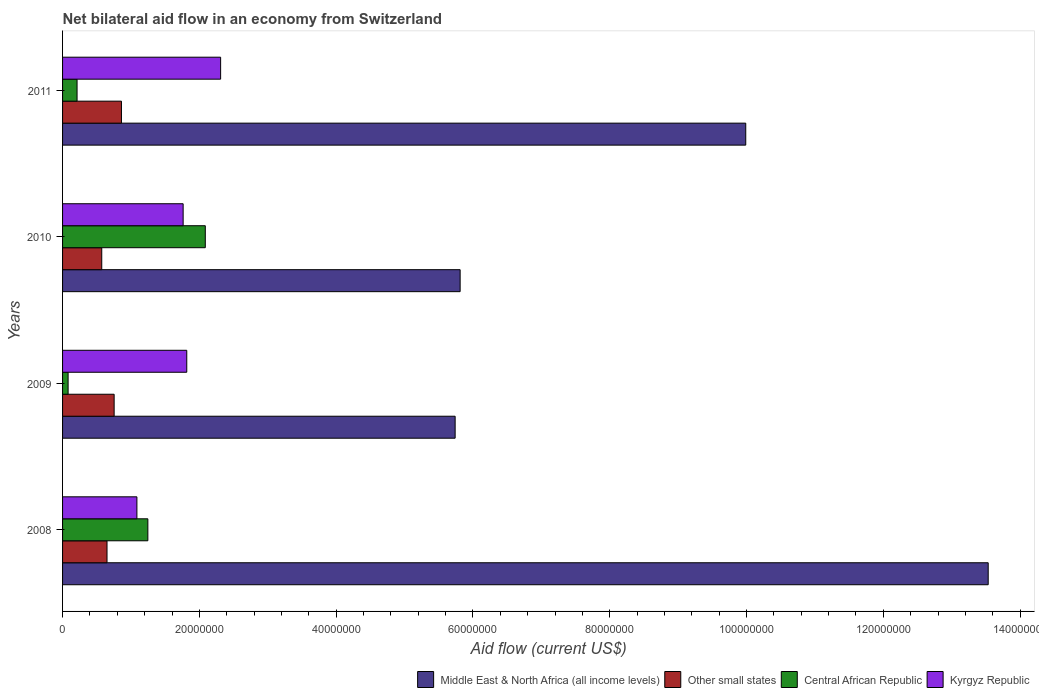Are the number of bars per tick equal to the number of legend labels?
Your answer should be very brief. Yes. How many bars are there on the 1st tick from the top?
Your response must be concise. 4. What is the net bilateral aid flow in Other small states in 2010?
Keep it short and to the point. 5.73e+06. Across all years, what is the maximum net bilateral aid flow in Middle East & North Africa (all income levels)?
Provide a short and direct response. 1.35e+08. Across all years, what is the minimum net bilateral aid flow in Middle East & North Africa (all income levels)?
Keep it short and to the point. 5.74e+07. What is the total net bilateral aid flow in Middle East & North Africa (all income levels) in the graph?
Provide a succinct answer. 3.51e+08. What is the difference between the net bilateral aid flow in Middle East & North Africa (all income levels) in 2008 and that in 2011?
Ensure brevity in your answer.  3.54e+07. What is the difference between the net bilateral aid flow in Kyrgyz Republic in 2009 and the net bilateral aid flow in Other small states in 2008?
Your answer should be very brief. 1.17e+07. What is the average net bilateral aid flow in Central African Republic per year?
Your answer should be very brief. 9.07e+06. In the year 2010, what is the difference between the net bilateral aid flow in Middle East & North Africa (all income levels) and net bilateral aid flow in Central African Republic?
Offer a terse response. 3.73e+07. What is the ratio of the net bilateral aid flow in Middle East & North Africa (all income levels) in 2008 to that in 2010?
Your answer should be compact. 2.33. What is the difference between the highest and the second highest net bilateral aid flow in Central African Republic?
Your response must be concise. 8.40e+06. What is the difference between the highest and the lowest net bilateral aid flow in Central African Republic?
Your answer should be compact. 2.01e+07. In how many years, is the net bilateral aid flow in Middle East & North Africa (all income levels) greater than the average net bilateral aid flow in Middle East & North Africa (all income levels) taken over all years?
Keep it short and to the point. 2. What does the 3rd bar from the top in 2009 represents?
Your response must be concise. Other small states. What does the 3rd bar from the bottom in 2011 represents?
Your answer should be very brief. Central African Republic. Is it the case that in every year, the sum of the net bilateral aid flow in Central African Republic and net bilateral aid flow in Kyrgyz Republic is greater than the net bilateral aid flow in Middle East & North Africa (all income levels)?
Offer a very short reply. No. Are all the bars in the graph horizontal?
Make the answer very short. Yes. What is the difference between two consecutive major ticks on the X-axis?
Offer a very short reply. 2.00e+07. Are the values on the major ticks of X-axis written in scientific E-notation?
Offer a very short reply. No. Does the graph contain grids?
Give a very brief answer. No. Where does the legend appear in the graph?
Ensure brevity in your answer.  Bottom right. How many legend labels are there?
Your answer should be very brief. 4. How are the legend labels stacked?
Your answer should be very brief. Horizontal. What is the title of the graph?
Ensure brevity in your answer.  Net bilateral aid flow in an economy from Switzerland. What is the Aid flow (current US$) of Middle East & North Africa (all income levels) in 2008?
Your answer should be very brief. 1.35e+08. What is the Aid flow (current US$) of Other small states in 2008?
Make the answer very short. 6.50e+06. What is the Aid flow (current US$) in Central African Republic in 2008?
Your answer should be very brief. 1.25e+07. What is the Aid flow (current US$) in Kyrgyz Republic in 2008?
Provide a succinct answer. 1.09e+07. What is the Aid flow (current US$) of Middle East & North Africa (all income levels) in 2009?
Give a very brief answer. 5.74e+07. What is the Aid flow (current US$) of Other small states in 2009?
Your answer should be compact. 7.54e+06. What is the Aid flow (current US$) of Central African Republic in 2009?
Give a very brief answer. 8.10e+05. What is the Aid flow (current US$) of Kyrgyz Republic in 2009?
Provide a short and direct response. 1.82e+07. What is the Aid flow (current US$) of Middle East & North Africa (all income levels) in 2010?
Make the answer very short. 5.81e+07. What is the Aid flow (current US$) of Other small states in 2010?
Provide a short and direct response. 5.73e+06. What is the Aid flow (current US$) of Central African Republic in 2010?
Ensure brevity in your answer.  2.09e+07. What is the Aid flow (current US$) of Kyrgyz Republic in 2010?
Provide a short and direct response. 1.76e+07. What is the Aid flow (current US$) of Middle East & North Africa (all income levels) in 2011?
Your answer should be compact. 9.99e+07. What is the Aid flow (current US$) in Other small states in 2011?
Keep it short and to the point. 8.61e+06. What is the Aid flow (current US$) in Central African Republic in 2011?
Offer a very short reply. 2.12e+06. What is the Aid flow (current US$) in Kyrgyz Republic in 2011?
Provide a succinct answer. 2.31e+07. Across all years, what is the maximum Aid flow (current US$) of Middle East & North Africa (all income levels)?
Your answer should be very brief. 1.35e+08. Across all years, what is the maximum Aid flow (current US$) in Other small states?
Your answer should be very brief. 8.61e+06. Across all years, what is the maximum Aid flow (current US$) in Central African Republic?
Offer a terse response. 2.09e+07. Across all years, what is the maximum Aid flow (current US$) in Kyrgyz Republic?
Give a very brief answer. 2.31e+07. Across all years, what is the minimum Aid flow (current US$) of Middle East & North Africa (all income levels)?
Your response must be concise. 5.74e+07. Across all years, what is the minimum Aid flow (current US$) of Other small states?
Give a very brief answer. 5.73e+06. Across all years, what is the minimum Aid flow (current US$) in Central African Republic?
Offer a very short reply. 8.10e+05. Across all years, what is the minimum Aid flow (current US$) of Kyrgyz Republic?
Offer a very short reply. 1.09e+07. What is the total Aid flow (current US$) in Middle East & North Africa (all income levels) in the graph?
Ensure brevity in your answer.  3.51e+08. What is the total Aid flow (current US$) of Other small states in the graph?
Offer a terse response. 2.84e+07. What is the total Aid flow (current US$) in Central African Republic in the graph?
Ensure brevity in your answer.  3.63e+07. What is the total Aid flow (current US$) in Kyrgyz Republic in the graph?
Keep it short and to the point. 6.98e+07. What is the difference between the Aid flow (current US$) in Middle East & North Africa (all income levels) in 2008 and that in 2009?
Ensure brevity in your answer.  7.79e+07. What is the difference between the Aid flow (current US$) in Other small states in 2008 and that in 2009?
Your answer should be very brief. -1.04e+06. What is the difference between the Aid flow (current US$) of Central African Republic in 2008 and that in 2009?
Make the answer very short. 1.17e+07. What is the difference between the Aid flow (current US$) of Kyrgyz Republic in 2008 and that in 2009?
Make the answer very short. -7.29e+06. What is the difference between the Aid flow (current US$) in Middle East & North Africa (all income levels) in 2008 and that in 2010?
Make the answer very short. 7.72e+07. What is the difference between the Aid flow (current US$) in Other small states in 2008 and that in 2010?
Give a very brief answer. 7.70e+05. What is the difference between the Aid flow (current US$) of Central African Republic in 2008 and that in 2010?
Your response must be concise. -8.40e+06. What is the difference between the Aid flow (current US$) in Kyrgyz Republic in 2008 and that in 2010?
Offer a very short reply. -6.76e+06. What is the difference between the Aid flow (current US$) of Middle East & North Africa (all income levels) in 2008 and that in 2011?
Ensure brevity in your answer.  3.54e+07. What is the difference between the Aid flow (current US$) of Other small states in 2008 and that in 2011?
Offer a terse response. -2.11e+06. What is the difference between the Aid flow (current US$) of Central African Republic in 2008 and that in 2011?
Ensure brevity in your answer.  1.04e+07. What is the difference between the Aid flow (current US$) in Kyrgyz Republic in 2008 and that in 2011?
Your answer should be compact. -1.22e+07. What is the difference between the Aid flow (current US$) of Middle East & North Africa (all income levels) in 2009 and that in 2010?
Your response must be concise. -7.30e+05. What is the difference between the Aid flow (current US$) in Other small states in 2009 and that in 2010?
Offer a terse response. 1.81e+06. What is the difference between the Aid flow (current US$) of Central African Republic in 2009 and that in 2010?
Your answer should be compact. -2.01e+07. What is the difference between the Aid flow (current US$) in Kyrgyz Republic in 2009 and that in 2010?
Provide a succinct answer. 5.30e+05. What is the difference between the Aid flow (current US$) of Middle East & North Africa (all income levels) in 2009 and that in 2011?
Keep it short and to the point. -4.25e+07. What is the difference between the Aid flow (current US$) of Other small states in 2009 and that in 2011?
Offer a very short reply. -1.07e+06. What is the difference between the Aid flow (current US$) in Central African Republic in 2009 and that in 2011?
Your answer should be very brief. -1.31e+06. What is the difference between the Aid flow (current US$) of Kyrgyz Republic in 2009 and that in 2011?
Provide a succinct answer. -4.95e+06. What is the difference between the Aid flow (current US$) of Middle East & North Africa (all income levels) in 2010 and that in 2011?
Offer a very short reply. -4.18e+07. What is the difference between the Aid flow (current US$) in Other small states in 2010 and that in 2011?
Your answer should be compact. -2.88e+06. What is the difference between the Aid flow (current US$) in Central African Republic in 2010 and that in 2011?
Your answer should be very brief. 1.88e+07. What is the difference between the Aid flow (current US$) of Kyrgyz Republic in 2010 and that in 2011?
Keep it short and to the point. -5.48e+06. What is the difference between the Aid flow (current US$) of Middle East & North Africa (all income levels) in 2008 and the Aid flow (current US$) of Other small states in 2009?
Give a very brief answer. 1.28e+08. What is the difference between the Aid flow (current US$) of Middle East & North Africa (all income levels) in 2008 and the Aid flow (current US$) of Central African Republic in 2009?
Give a very brief answer. 1.35e+08. What is the difference between the Aid flow (current US$) in Middle East & North Africa (all income levels) in 2008 and the Aid flow (current US$) in Kyrgyz Republic in 2009?
Provide a succinct answer. 1.17e+08. What is the difference between the Aid flow (current US$) in Other small states in 2008 and the Aid flow (current US$) in Central African Republic in 2009?
Your answer should be compact. 5.69e+06. What is the difference between the Aid flow (current US$) in Other small states in 2008 and the Aid flow (current US$) in Kyrgyz Republic in 2009?
Make the answer very short. -1.17e+07. What is the difference between the Aid flow (current US$) in Central African Republic in 2008 and the Aid flow (current US$) in Kyrgyz Republic in 2009?
Offer a terse response. -5.69e+06. What is the difference between the Aid flow (current US$) in Middle East & North Africa (all income levels) in 2008 and the Aid flow (current US$) in Other small states in 2010?
Your answer should be very brief. 1.30e+08. What is the difference between the Aid flow (current US$) in Middle East & North Africa (all income levels) in 2008 and the Aid flow (current US$) in Central African Republic in 2010?
Provide a succinct answer. 1.14e+08. What is the difference between the Aid flow (current US$) of Middle East & North Africa (all income levels) in 2008 and the Aid flow (current US$) of Kyrgyz Republic in 2010?
Make the answer very short. 1.18e+08. What is the difference between the Aid flow (current US$) in Other small states in 2008 and the Aid flow (current US$) in Central African Republic in 2010?
Your answer should be very brief. -1.44e+07. What is the difference between the Aid flow (current US$) in Other small states in 2008 and the Aid flow (current US$) in Kyrgyz Republic in 2010?
Provide a short and direct response. -1.11e+07. What is the difference between the Aid flow (current US$) in Central African Republic in 2008 and the Aid flow (current US$) in Kyrgyz Republic in 2010?
Offer a terse response. -5.16e+06. What is the difference between the Aid flow (current US$) of Middle East & North Africa (all income levels) in 2008 and the Aid flow (current US$) of Other small states in 2011?
Keep it short and to the point. 1.27e+08. What is the difference between the Aid flow (current US$) in Middle East & North Africa (all income levels) in 2008 and the Aid flow (current US$) in Central African Republic in 2011?
Offer a terse response. 1.33e+08. What is the difference between the Aid flow (current US$) of Middle East & North Africa (all income levels) in 2008 and the Aid flow (current US$) of Kyrgyz Republic in 2011?
Your answer should be very brief. 1.12e+08. What is the difference between the Aid flow (current US$) of Other small states in 2008 and the Aid flow (current US$) of Central African Republic in 2011?
Give a very brief answer. 4.38e+06. What is the difference between the Aid flow (current US$) of Other small states in 2008 and the Aid flow (current US$) of Kyrgyz Republic in 2011?
Offer a very short reply. -1.66e+07. What is the difference between the Aid flow (current US$) of Central African Republic in 2008 and the Aid flow (current US$) of Kyrgyz Republic in 2011?
Provide a short and direct response. -1.06e+07. What is the difference between the Aid flow (current US$) in Middle East & North Africa (all income levels) in 2009 and the Aid flow (current US$) in Other small states in 2010?
Your response must be concise. 5.17e+07. What is the difference between the Aid flow (current US$) of Middle East & North Africa (all income levels) in 2009 and the Aid flow (current US$) of Central African Republic in 2010?
Make the answer very short. 3.65e+07. What is the difference between the Aid flow (current US$) of Middle East & North Africa (all income levels) in 2009 and the Aid flow (current US$) of Kyrgyz Republic in 2010?
Ensure brevity in your answer.  3.98e+07. What is the difference between the Aid flow (current US$) in Other small states in 2009 and the Aid flow (current US$) in Central African Republic in 2010?
Provide a short and direct response. -1.33e+07. What is the difference between the Aid flow (current US$) of Other small states in 2009 and the Aid flow (current US$) of Kyrgyz Republic in 2010?
Keep it short and to the point. -1.01e+07. What is the difference between the Aid flow (current US$) of Central African Republic in 2009 and the Aid flow (current US$) of Kyrgyz Republic in 2010?
Keep it short and to the point. -1.68e+07. What is the difference between the Aid flow (current US$) of Middle East & North Africa (all income levels) in 2009 and the Aid flow (current US$) of Other small states in 2011?
Offer a terse response. 4.88e+07. What is the difference between the Aid flow (current US$) in Middle East & North Africa (all income levels) in 2009 and the Aid flow (current US$) in Central African Republic in 2011?
Give a very brief answer. 5.53e+07. What is the difference between the Aid flow (current US$) of Middle East & North Africa (all income levels) in 2009 and the Aid flow (current US$) of Kyrgyz Republic in 2011?
Provide a short and direct response. 3.43e+07. What is the difference between the Aid flow (current US$) of Other small states in 2009 and the Aid flow (current US$) of Central African Republic in 2011?
Your response must be concise. 5.42e+06. What is the difference between the Aid flow (current US$) of Other small states in 2009 and the Aid flow (current US$) of Kyrgyz Republic in 2011?
Offer a very short reply. -1.56e+07. What is the difference between the Aid flow (current US$) of Central African Republic in 2009 and the Aid flow (current US$) of Kyrgyz Republic in 2011?
Offer a terse response. -2.23e+07. What is the difference between the Aid flow (current US$) in Middle East & North Africa (all income levels) in 2010 and the Aid flow (current US$) in Other small states in 2011?
Provide a short and direct response. 4.95e+07. What is the difference between the Aid flow (current US$) of Middle East & North Africa (all income levels) in 2010 and the Aid flow (current US$) of Central African Republic in 2011?
Your response must be concise. 5.60e+07. What is the difference between the Aid flow (current US$) of Middle East & North Africa (all income levels) in 2010 and the Aid flow (current US$) of Kyrgyz Republic in 2011?
Ensure brevity in your answer.  3.50e+07. What is the difference between the Aid flow (current US$) of Other small states in 2010 and the Aid flow (current US$) of Central African Republic in 2011?
Provide a succinct answer. 3.61e+06. What is the difference between the Aid flow (current US$) of Other small states in 2010 and the Aid flow (current US$) of Kyrgyz Republic in 2011?
Give a very brief answer. -1.74e+07. What is the difference between the Aid flow (current US$) of Central African Republic in 2010 and the Aid flow (current US$) of Kyrgyz Republic in 2011?
Provide a short and direct response. -2.24e+06. What is the average Aid flow (current US$) in Middle East & North Africa (all income levels) per year?
Provide a succinct answer. 8.77e+07. What is the average Aid flow (current US$) of Other small states per year?
Provide a short and direct response. 7.10e+06. What is the average Aid flow (current US$) of Central African Republic per year?
Provide a short and direct response. 9.07e+06. What is the average Aid flow (current US$) of Kyrgyz Republic per year?
Offer a very short reply. 1.74e+07. In the year 2008, what is the difference between the Aid flow (current US$) in Middle East & North Africa (all income levels) and Aid flow (current US$) in Other small states?
Your answer should be compact. 1.29e+08. In the year 2008, what is the difference between the Aid flow (current US$) in Middle East & North Africa (all income levels) and Aid flow (current US$) in Central African Republic?
Your response must be concise. 1.23e+08. In the year 2008, what is the difference between the Aid flow (current US$) in Middle East & North Africa (all income levels) and Aid flow (current US$) in Kyrgyz Republic?
Your answer should be very brief. 1.24e+08. In the year 2008, what is the difference between the Aid flow (current US$) in Other small states and Aid flow (current US$) in Central African Republic?
Offer a very short reply. -5.97e+06. In the year 2008, what is the difference between the Aid flow (current US$) in Other small states and Aid flow (current US$) in Kyrgyz Republic?
Offer a very short reply. -4.37e+06. In the year 2008, what is the difference between the Aid flow (current US$) in Central African Republic and Aid flow (current US$) in Kyrgyz Republic?
Ensure brevity in your answer.  1.60e+06. In the year 2009, what is the difference between the Aid flow (current US$) in Middle East & North Africa (all income levels) and Aid flow (current US$) in Other small states?
Your answer should be compact. 4.99e+07. In the year 2009, what is the difference between the Aid flow (current US$) of Middle East & North Africa (all income levels) and Aid flow (current US$) of Central African Republic?
Your response must be concise. 5.66e+07. In the year 2009, what is the difference between the Aid flow (current US$) in Middle East & North Africa (all income levels) and Aid flow (current US$) in Kyrgyz Republic?
Provide a succinct answer. 3.92e+07. In the year 2009, what is the difference between the Aid flow (current US$) in Other small states and Aid flow (current US$) in Central African Republic?
Your answer should be very brief. 6.73e+06. In the year 2009, what is the difference between the Aid flow (current US$) of Other small states and Aid flow (current US$) of Kyrgyz Republic?
Provide a succinct answer. -1.06e+07. In the year 2009, what is the difference between the Aid flow (current US$) of Central African Republic and Aid flow (current US$) of Kyrgyz Republic?
Provide a short and direct response. -1.74e+07. In the year 2010, what is the difference between the Aid flow (current US$) in Middle East & North Africa (all income levels) and Aid flow (current US$) in Other small states?
Provide a short and direct response. 5.24e+07. In the year 2010, what is the difference between the Aid flow (current US$) of Middle East & North Africa (all income levels) and Aid flow (current US$) of Central African Republic?
Make the answer very short. 3.73e+07. In the year 2010, what is the difference between the Aid flow (current US$) of Middle East & North Africa (all income levels) and Aid flow (current US$) of Kyrgyz Republic?
Provide a succinct answer. 4.05e+07. In the year 2010, what is the difference between the Aid flow (current US$) in Other small states and Aid flow (current US$) in Central African Republic?
Offer a very short reply. -1.51e+07. In the year 2010, what is the difference between the Aid flow (current US$) in Other small states and Aid flow (current US$) in Kyrgyz Republic?
Your response must be concise. -1.19e+07. In the year 2010, what is the difference between the Aid flow (current US$) in Central African Republic and Aid flow (current US$) in Kyrgyz Republic?
Keep it short and to the point. 3.24e+06. In the year 2011, what is the difference between the Aid flow (current US$) of Middle East & North Africa (all income levels) and Aid flow (current US$) of Other small states?
Offer a terse response. 9.13e+07. In the year 2011, what is the difference between the Aid flow (current US$) of Middle East & North Africa (all income levels) and Aid flow (current US$) of Central African Republic?
Your answer should be compact. 9.78e+07. In the year 2011, what is the difference between the Aid flow (current US$) in Middle East & North Africa (all income levels) and Aid flow (current US$) in Kyrgyz Republic?
Your answer should be very brief. 7.68e+07. In the year 2011, what is the difference between the Aid flow (current US$) of Other small states and Aid flow (current US$) of Central African Republic?
Make the answer very short. 6.49e+06. In the year 2011, what is the difference between the Aid flow (current US$) in Other small states and Aid flow (current US$) in Kyrgyz Republic?
Give a very brief answer. -1.45e+07. In the year 2011, what is the difference between the Aid flow (current US$) of Central African Republic and Aid flow (current US$) of Kyrgyz Republic?
Offer a terse response. -2.10e+07. What is the ratio of the Aid flow (current US$) in Middle East & North Africa (all income levels) in 2008 to that in 2009?
Your response must be concise. 2.36. What is the ratio of the Aid flow (current US$) in Other small states in 2008 to that in 2009?
Keep it short and to the point. 0.86. What is the ratio of the Aid flow (current US$) in Central African Republic in 2008 to that in 2009?
Ensure brevity in your answer.  15.4. What is the ratio of the Aid flow (current US$) in Kyrgyz Republic in 2008 to that in 2009?
Provide a succinct answer. 0.6. What is the ratio of the Aid flow (current US$) in Middle East & North Africa (all income levels) in 2008 to that in 2010?
Give a very brief answer. 2.33. What is the ratio of the Aid flow (current US$) in Other small states in 2008 to that in 2010?
Your response must be concise. 1.13. What is the ratio of the Aid flow (current US$) of Central African Republic in 2008 to that in 2010?
Provide a short and direct response. 0.6. What is the ratio of the Aid flow (current US$) in Kyrgyz Republic in 2008 to that in 2010?
Offer a very short reply. 0.62. What is the ratio of the Aid flow (current US$) of Middle East & North Africa (all income levels) in 2008 to that in 2011?
Make the answer very short. 1.35. What is the ratio of the Aid flow (current US$) of Other small states in 2008 to that in 2011?
Your answer should be compact. 0.75. What is the ratio of the Aid flow (current US$) of Central African Republic in 2008 to that in 2011?
Your response must be concise. 5.88. What is the ratio of the Aid flow (current US$) of Kyrgyz Republic in 2008 to that in 2011?
Keep it short and to the point. 0.47. What is the ratio of the Aid flow (current US$) of Middle East & North Africa (all income levels) in 2009 to that in 2010?
Offer a very short reply. 0.99. What is the ratio of the Aid flow (current US$) in Other small states in 2009 to that in 2010?
Your answer should be compact. 1.32. What is the ratio of the Aid flow (current US$) in Central African Republic in 2009 to that in 2010?
Your answer should be compact. 0.04. What is the ratio of the Aid flow (current US$) of Kyrgyz Republic in 2009 to that in 2010?
Make the answer very short. 1.03. What is the ratio of the Aid flow (current US$) of Middle East & North Africa (all income levels) in 2009 to that in 2011?
Give a very brief answer. 0.57. What is the ratio of the Aid flow (current US$) in Other small states in 2009 to that in 2011?
Provide a succinct answer. 0.88. What is the ratio of the Aid flow (current US$) of Central African Republic in 2009 to that in 2011?
Make the answer very short. 0.38. What is the ratio of the Aid flow (current US$) in Kyrgyz Republic in 2009 to that in 2011?
Provide a short and direct response. 0.79. What is the ratio of the Aid flow (current US$) in Middle East & North Africa (all income levels) in 2010 to that in 2011?
Your response must be concise. 0.58. What is the ratio of the Aid flow (current US$) in Other small states in 2010 to that in 2011?
Your answer should be compact. 0.67. What is the ratio of the Aid flow (current US$) of Central African Republic in 2010 to that in 2011?
Keep it short and to the point. 9.84. What is the ratio of the Aid flow (current US$) in Kyrgyz Republic in 2010 to that in 2011?
Make the answer very short. 0.76. What is the difference between the highest and the second highest Aid flow (current US$) in Middle East & North Africa (all income levels)?
Your answer should be compact. 3.54e+07. What is the difference between the highest and the second highest Aid flow (current US$) of Other small states?
Make the answer very short. 1.07e+06. What is the difference between the highest and the second highest Aid flow (current US$) in Central African Republic?
Provide a short and direct response. 8.40e+06. What is the difference between the highest and the second highest Aid flow (current US$) of Kyrgyz Republic?
Keep it short and to the point. 4.95e+06. What is the difference between the highest and the lowest Aid flow (current US$) in Middle East & North Africa (all income levels)?
Your response must be concise. 7.79e+07. What is the difference between the highest and the lowest Aid flow (current US$) of Other small states?
Offer a terse response. 2.88e+06. What is the difference between the highest and the lowest Aid flow (current US$) of Central African Republic?
Offer a very short reply. 2.01e+07. What is the difference between the highest and the lowest Aid flow (current US$) in Kyrgyz Republic?
Give a very brief answer. 1.22e+07. 